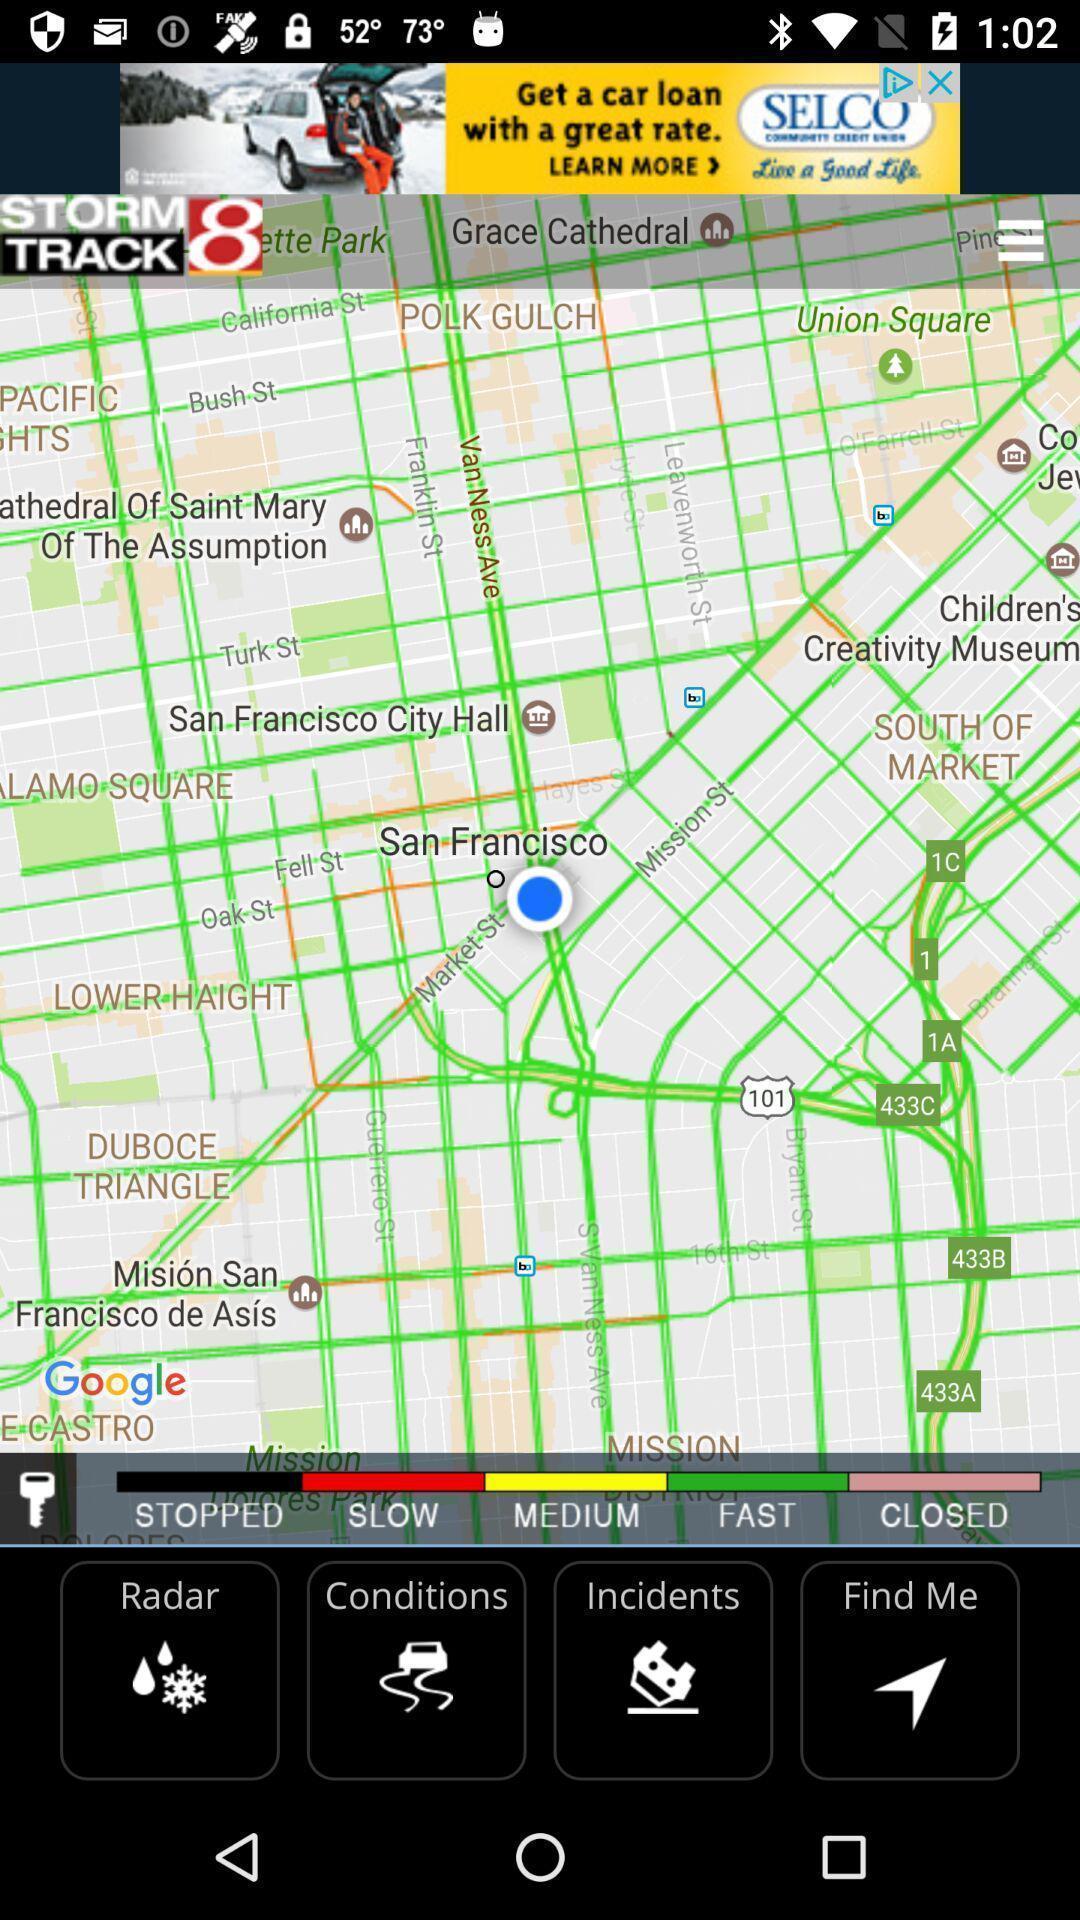What is the overall content of this screenshot? Screen shows about weather conditions. 